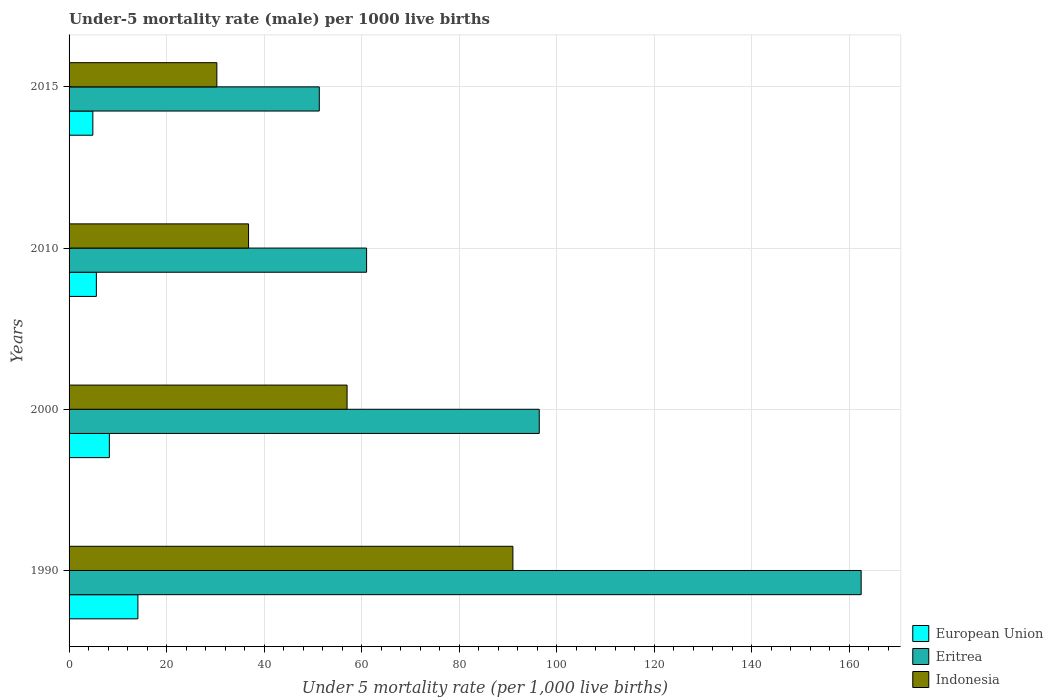How many groups of bars are there?
Your answer should be very brief. 4. Are the number of bars per tick equal to the number of legend labels?
Your answer should be compact. Yes. Are the number of bars on each tick of the Y-axis equal?
Provide a short and direct response. Yes. How many bars are there on the 3rd tick from the top?
Make the answer very short. 3. In how many cases, is the number of bars for a given year not equal to the number of legend labels?
Your response must be concise. 0. What is the under-five mortality rate in Eritrea in 2015?
Your answer should be very brief. 51.3. Across all years, what is the maximum under-five mortality rate in Indonesia?
Offer a terse response. 91. Across all years, what is the minimum under-five mortality rate in Eritrea?
Offer a very short reply. 51.3. In which year was the under-five mortality rate in Eritrea maximum?
Make the answer very short. 1990. In which year was the under-five mortality rate in Indonesia minimum?
Offer a very short reply. 2015. What is the total under-five mortality rate in Eritrea in the graph?
Offer a very short reply. 371.1. What is the difference between the under-five mortality rate in Eritrea in 2010 and that in 2015?
Give a very brief answer. 9.7. What is the difference between the under-five mortality rate in Eritrea in 1990 and the under-five mortality rate in European Union in 2015?
Offer a very short reply. 157.52. What is the average under-five mortality rate in Eritrea per year?
Offer a very short reply. 92.78. In the year 2015, what is the difference between the under-five mortality rate in Indonesia and under-five mortality rate in Eritrea?
Provide a short and direct response. -21. What is the ratio of the under-five mortality rate in Eritrea in 1990 to that in 2010?
Offer a very short reply. 2.66. Is the under-five mortality rate in Indonesia in 1990 less than that in 2010?
Give a very brief answer. No. Is the difference between the under-five mortality rate in Indonesia in 2010 and 2015 greater than the difference between the under-five mortality rate in Eritrea in 2010 and 2015?
Offer a very short reply. No. What is the difference between the highest and the second highest under-five mortality rate in European Union?
Offer a terse response. 5.85. What is the difference between the highest and the lowest under-five mortality rate in European Union?
Provide a succinct answer. 9.23. In how many years, is the under-five mortality rate in Eritrea greater than the average under-five mortality rate in Eritrea taken over all years?
Provide a short and direct response. 2. Is the sum of the under-five mortality rate in Indonesia in 1990 and 2010 greater than the maximum under-five mortality rate in Eritrea across all years?
Your answer should be very brief. No. What does the 1st bar from the top in 1990 represents?
Your answer should be very brief. Indonesia. What does the 1st bar from the bottom in 2015 represents?
Your answer should be very brief. European Union. How many years are there in the graph?
Offer a terse response. 4. What is the difference between two consecutive major ticks on the X-axis?
Your response must be concise. 20. Does the graph contain any zero values?
Your answer should be very brief. No. Does the graph contain grids?
Offer a terse response. Yes. Where does the legend appear in the graph?
Give a very brief answer. Bottom right. What is the title of the graph?
Make the answer very short. Under-5 mortality rate (male) per 1000 live births. What is the label or title of the X-axis?
Provide a succinct answer. Under 5 mortality rate (per 1,0 live births). What is the label or title of the Y-axis?
Your answer should be very brief. Years. What is the Under 5 mortality rate (per 1,000 live births) of European Union in 1990?
Offer a terse response. 14.11. What is the Under 5 mortality rate (per 1,000 live births) in Eritrea in 1990?
Provide a succinct answer. 162.4. What is the Under 5 mortality rate (per 1,000 live births) in Indonesia in 1990?
Ensure brevity in your answer.  91. What is the Under 5 mortality rate (per 1,000 live births) in European Union in 2000?
Offer a very short reply. 8.26. What is the Under 5 mortality rate (per 1,000 live births) of Eritrea in 2000?
Give a very brief answer. 96.4. What is the Under 5 mortality rate (per 1,000 live births) of European Union in 2010?
Ensure brevity in your answer.  5.6. What is the Under 5 mortality rate (per 1,000 live births) of Eritrea in 2010?
Your answer should be compact. 61. What is the Under 5 mortality rate (per 1,000 live births) of Indonesia in 2010?
Provide a succinct answer. 36.8. What is the Under 5 mortality rate (per 1,000 live births) in European Union in 2015?
Give a very brief answer. 4.88. What is the Under 5 mortality rate (per 1,000 live births) of Eritrea in 2015?
Make the answer very short. 51.3. What is the Under 5 mortality rate (per 1,000 live births) of Indonesia in 2015?
Your answer should be very brief. 30.3. Across all years, what is the maximum Under 5 mortality rate (per 1,000 live births) in European Union?
Ensure brevity in your answer.  14.11. Across all years, what is the maximum Under 5 mortality rate (per 1,000 live births) of Eritrea?
Keep it short and to the point. 162.4. Across all years, what is the maximum Under 5 mortality rate (per 1,000 live births) of Indonesia?
Make the answer very short. 91. Across all years, what is the minimum Under 5 mortality rate (per 1,000 live births) in European Union?
Your answer should be very brief. 4.88. Across all years, what is the minimum Under 5 mortality rate (per 1,000 live births) in Eritrea?
Offer a very short reply. 51.3. Across all years, what is the minimum Under 5 mortality rate (per 1,000 live births) in Indonesia?
Offer a terse response. 30.3. What is the total Under 5 mortality rate (per 1,000 live births) in European Union in the graph?
Your answer should be compact. 32.84. What is the total Under 5 mortality rate (per 1,000 live births) of Eritrea in the graph?
Give a very brief answer. 371.1. What is the total Under 5 mortality rate (per 1,000 live births) in Indonesia in the graph?
Keep it short and to the point. 215.1. What is the difference between the Under 5 mortality rate (per 1,000 live births) of European Union in 1990 and that in 2000?
Your answer should be very brief. 5.85. What is the difference between the Under 5 mortality rate (per 1,000 live births) of Indonesia in 1990 and that in 2000?
Offer a terse response. 34. What is the difference between the Under 5 mortality rate (per 1,000 live births) of European Union in 1990 and that in 2010?
Ensure brevity in your answer.  8.51. What is the difference between the Under 5 mortality rate (per 1,000 live births) of Eritrea in 1990 and that in 2010?
Your answer should be very brief. 101.4. What is the difference between the Under 5 mortality rate (per 1,000 live births) in Indonesia in 1990 and that in 2010?
Offer a very short reply. 54.2. What is the difference between the Under 5 mortality rate (per 1,000 live births) in European Union in 1990 and that in 2015?
Make the answer very short. 9.23. What is the difference between the Under 5 mortality rate (per 1,000 live births) in Eritrea in 1990 and that in 2015?
Your answer should be very brief. 111.1. What is the difference between the Under 5 mortality rate (per 1,000 live births) of Indonesia in 1990 and that in 2015?
Provide a succinct answer. 60.7. What is the difference between the Under 5 mortality rate (per 1,000 live births) of European Union in 2000 and that in 2010?
Your answer should be compact. 2.66. What is the difference between the Under 5 mortality rate (per 1,000 live births) of Eritrea in 2000 and that in 2010?
Make the answer very short. 35.4. What is the difference between the Under 5 mortality rate (per 1,000 live births) in Indonesia in 2000 and that in 2010?
Keep it short and to the point. 20.2. What is the difference between the Under 5 mortality rate (per 1,000 live births) in European Union in 2000 and that in 2015?
Keep it short and to the point. 3.38. What is the difference between the Under 5 mortality rate (per 1,000 live births) of Eritrea in 2000 and that in 2015?
Your answer should be compact. 45.1. What is the difference between the Under 5 mortality rate (per 1,000 live births) of Indonesia in 2000 and that in 2015?
Your answer should be very brief. 26.7. What is the difference between the Under 5 mortality rate (per 1,000 live births) in European Union in 2010 and that in 2015?
Offer a terse response. 0.72. What is the difference between the Under 5 mortality rate (per 1,000 live births) in European Union in 1990 and the Under 5 mortality rate (per 1,000 live births) in Eritrea in 2000?
Give a very brief answer. -82.29. What is the difference between the Under 5 mortality rate (per 1,000 live births) in European Union in 1990 and the Under 5 mortality rate (per 1,000 live births) in Indonesia in 2000?
Offer a terse response. -42.89. What is the difference between the Under 5 mortality rate (per 1,000 live births) of Eritrea in 1990 and the Under 5 mortality rate (per 1,000 live births) of Indonesia in 2000?
Offer a terse response. 105.4. What is the difference between the Under 5 mortality rate (per 1,000 live births) in European Union in 1990 and the Under 5 mortality rate (per 1,000 live births) in Eritrea in 2010?
Offer a very short reply. -46.89. What is the difference between the Under 5 mortality rate (per 1,000 live births) of European Union in 1990 and the Under 5 mortality rate (per 1,000 live births) of Indonesia in 2010?
Your answer should be very brief. -22.69. What is the difference between the Under 5 mortality rate (per 1,000 live births) in Eritrea in 1990 and the Under 5 mortality rate (per 1,000 live births) in Indonesia in 2010?
Your answer should be very brief. 125.6. What is the difference between the Under 5 mortality rate (per 1,000 live births) in European Union in 1990 and the Under 5 mortality rate (per 1,000 live births) in Eritrea in 2015?
Provide a short and direct response. -37.19. What is the difference between the Under 5 mortality rate (per 1,000 live births) of European Union in 1990 and the Under 5 mortality rate (per 1,000 live births) of Indonesia in 2015?
Make the answer very short. -16.19. What is the difference between the Under 5 mortality rate (per 1,000 live births) of Eritrea in 1990 and the Under 5 mortality rate (per 1,000 live births) of Indonesia in 2015?
Your answer should be very brief. 132.1. What is the difference between the Under 5 mortality rate (per 1,000 live births) in European Union in 2000 and the Under 5 mortality rate (per 1,000 live births) in Eritrea in 2010?
Provide a succinct answer. -52.74. What is the difference between the Under 5 mortality rate (per 1,000 live births) of European Union in 2000 and the Under 5 mortality rate (per 1,000 live births) of Indonesia in 2010?
Keep it short and to the point. -28.54. What is the difference between the Under 5 mortality rate (per 1,000 live births) of Eritrea in 2000 and the Under 5 mortality rate (per 1,000 live births) of Indonesia in 2010?
Give a very brief answer. 59.6. What is the difference between the Under 5 mortality rate (per 1,000 live births) in European Union in 2000 and the Under 5 mortality rate (per 1,000 live births) in Eritrea in 2015?
Give a very brief answer. -43.04. What is the difference between the Under 5 mortality rate (per 1,000 live births) in European Union in 2000 and the Under 5 mortality rate (per 1,000 live births) in Indonesia in 2015?
Offer a terse response. -22.04. What is the difference between the Under 5 mortality rate (per 1,000 live births) in Eritrea in 2000 and the Under 5 mortality rate (per 1,000 live births) in Indonesia in 2015?
Offer a terse response. 66.1. What is the difference between the Under 5 mortality rate (per 1,000 live births) in European Union in 2010 and the Under 5 mortality rate (per 1,000 live births) in Eritrea in 2015?
Your response must be concise. -45.7. What is the difference between the Under 5 mortality rate (per 1,000 live births) in European Union in 2010 and the Under 5 mortality rate (per 1,000 live births) in Indonesia in 2015?
Ensure brevity in your answer.  -24.7. What is the difference between the Under 5 mortality rate (per 1,000 live births) of Eritrea in 2010 and the Under 5 mortality rate (per 1,000 live births) of Indonesia in 2015?
Offer a terse response. 30.7. What is the average Under 5 mortality rate (per 1,000 live births) of European Union per year?
Your answer should be compact. 8.21. What is the average Under 5 mortality rate (per 1,000 live births) of Eritrea per year?
Your answer should be very brief. 92.78. What is the average Under 5 mortality rate (per 1,000 live births) of Indonesia per year?
Provide a short and direct response. 53.77. In the year 1990, what is the difference between the Under 5 mortality rate (per 1,000 live births) of European Union and Under 5 mortality rate (per 1,000 live births) of Eritrea?
Your answer should be compact. -148.29. In the year 1990, what is the difference between the Under 5 mortality rate (per 1,000 live births) of European Union and Under 5 mortality rate (per 1,000 live births) of Indonesia?
Your answer should be very brief. -76.89. In the year 1990, what is the difference between the Under 5 mortality rate (per 1,000 live births) in Eritrea and Under 5 mortality rate (per 1,000 live births) in Indonesia?
Offer a very short reply. 71.4. In the year 2000, what is the difference between the Under 5 mortality rate (per 1,000 live births) in European Union and Under 5 mortality rate (per 1,000 live births) in Eritrea?
Give a very brief answer. -88.14. In the year 2000, what is the difference between the Under 5 mortality rate (per 1,000 live births) in European Union and Under 5 mortality rate (per 1,000 live births) in Indonesia?
Offer a very short reply. -48.74. In the year 2000, what is the difference between the Under 5 mortality rate (per 1,000 live births) in Eritrea and Under 5 mortality rate (per 1,000 live births) in Indonesia?
Offer a very short reply. 39.4. In the year 2010, what is the difference between the Under 5 mortality rate (per 1,000 live births) of European Union and Under 5 mortality rate (per 1,000 live births) of Eritrea?
Keep it short and to the point. -55.4. In the year 2010, what is the difference between the Under 5 mortality rate (per 1,000 live births) in European Union and Under 5 mortality rate (per 1,000 live births) in Indonesia?
Give a very brief answer. -31.2. In the year 2010, what is the difference between the Under 5 mortality rate (per 1,000 live births) in Eritrea and Under 5 mortality rate (per 1,000 live births) in Indonesia?
Provide a short and direct response. 24.2. In the year 2015, what is the difference between the Under 5 mortality rate (per 1,000 live births) of European Union and Under 5 mortality rate (per 1,000 live births) of Eritrea?
Your answer should be very brief. -46.42. In the year 2015, what is the difference between the Under 5 mortality rate (per 1,000 live births) of European Union and Under 5 mortality rate (per 1,000 live births) of Indonesia?
Your response must be concise. -25.42. What is the ratio of the Under 5 mortality rate (per 1,000 live births) of European Union in 1990 to that in 2000?
Provide a succinct answer. 1.71. What is the ratio of the Under 5 mortality rate (per 1,000 live births) in Eritrea in 1990 to that in 2000?
Offer a very short reply. 1.68. What is the ratio of the Under 5 mortality rate (per 1,000 live births) in Indonesia in 1990 to that in 2000?
Make the answer very short. 1.6. What is the ratio of the Under 5 mortality rate (per 1,000 live births) in European Union in 1990 to that in 2010?
Your answer should be very brief. 2.52. What is the ratio of the Under 5 mortality rate (per 1,000 live births) in Eritrea in 1990 to that in 2010?
Provide a succinct answer. 2.66. What is the ratio of the Under 5 mortality rate (per 1,000 live births) in Indonesia in 1990 to that in 2010?
Your response must be concise. 2.47. What is the ratio of the Under 5 mortality rate (per 1,000 live births) of European Union in 1990 to that in 2015?
Ensure brevity in your answer.  2.89. What is the ratio of the Under 5 mortality rate (per 1,000 live births) in Eritrea in 1990 to that in 2015?
Your answer should be very brief. 3.17. What is the ratio of the Under 5 mortality rate (per 1,000 live births) of Indonesia in 1990 to that in 2015?
Provide a short and direct response. 3. What is the ratio of the Under 5 mortality rate (per 1,000 live births) of European Union in 2000 to that in 2010?
Offer a very short reply. 1.48. What is the ratio of the Under 5 mortality rate (per 1,000 live births) of Eritrea in 2000 to that in 2010?
Your answer should be compact. 1.58. What is the ratio of the Under 5 mortality rate (per 1,000 live births) in Indonesia in 2000 to that in 2010?
Ensure brevity in your answer.  1.55. What is the ratio of the Under 5 mortality rate (per 1,000 live births) of European Union in 2000 to that in 2015?
Give a very brief answer. 1.69. What is the ratio of the Under 5 mortality rate (per 1,000 live births) in Eritrea in 2000 to that in 2015?
Give a very brief answer. 1.88. What is the ratio of the Under 5 mortality rate (per 1,000 live births) of Indonesia in 2000 to that in 2015?
Make the answer very short. 1.88. What is the ratio of the Under 5 mortality rate (per 1,000 live births) in European Union in 2010 to that in 2015?
Your response must be concise. 1.15. What is the ratio of the Under 5 mortality rate (per 1,000 live births) of Eritrea in 2010 to that in 2015?
Give a very brief answer. 1.19. What is the ratio of the Under 5 mortality rate (per 1,000 live births) in Indonesia in 2010 to that in 2015?
Provide a short and direct response. 1.21. What is the difference between the highest and the second highest Under 5 mortality rate (per 1,000 live births) of European Union?
Your response must be concise. 5.85. What is the difference between the highest and the lowest Under 5 mortality rate (per 1,000 live births) in European Union?
Give a very brief answer. 9.23. What is the difference between the highest and the lowest Under 5 mortality rate (per 1,000 live births) of Eritrea?
Ensure brevity in your answer.  111.1. What is the difference between the highest and the lowest Under 5 mortality rate (per 1,000 live births) in Indonesia?
Ensure brevity in your answer.  60.7. 